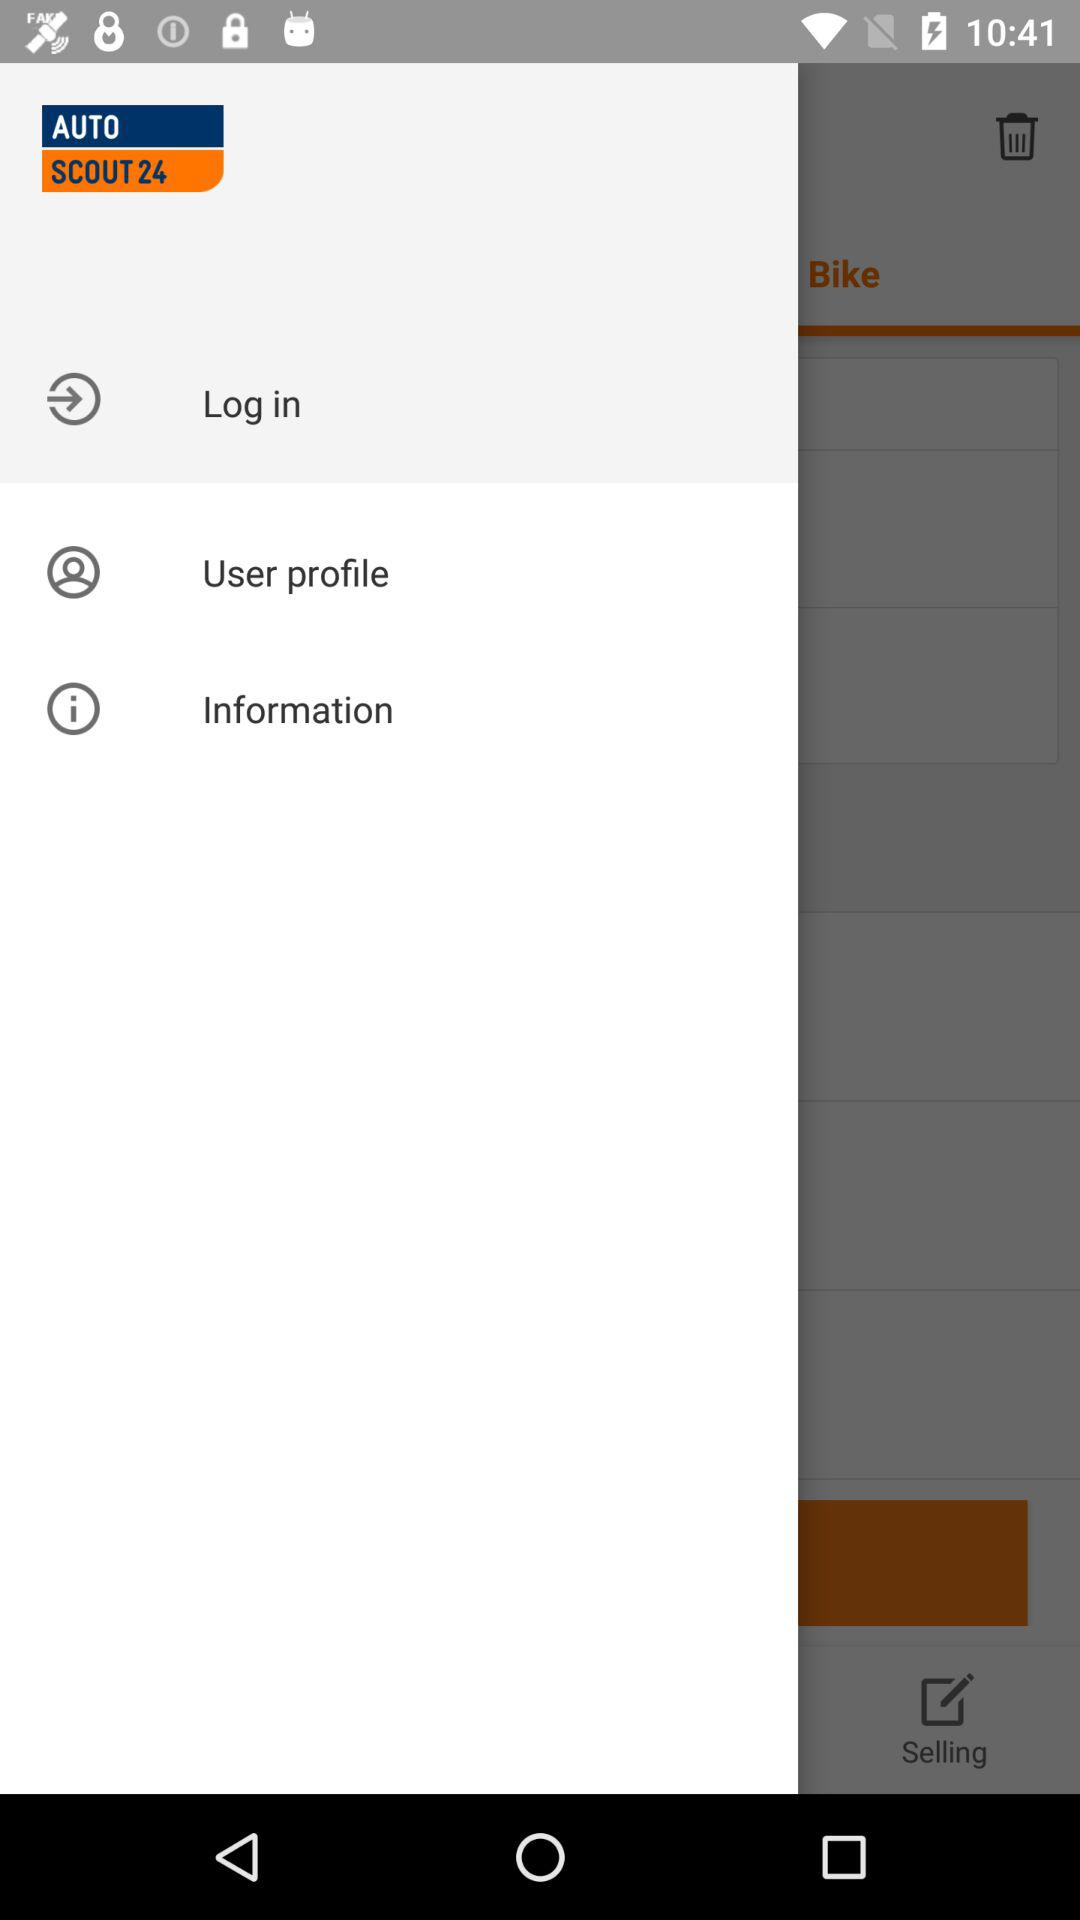What is the user's profile name?
When the provided information is insufficient, respond with <no answer>. <no answer> 